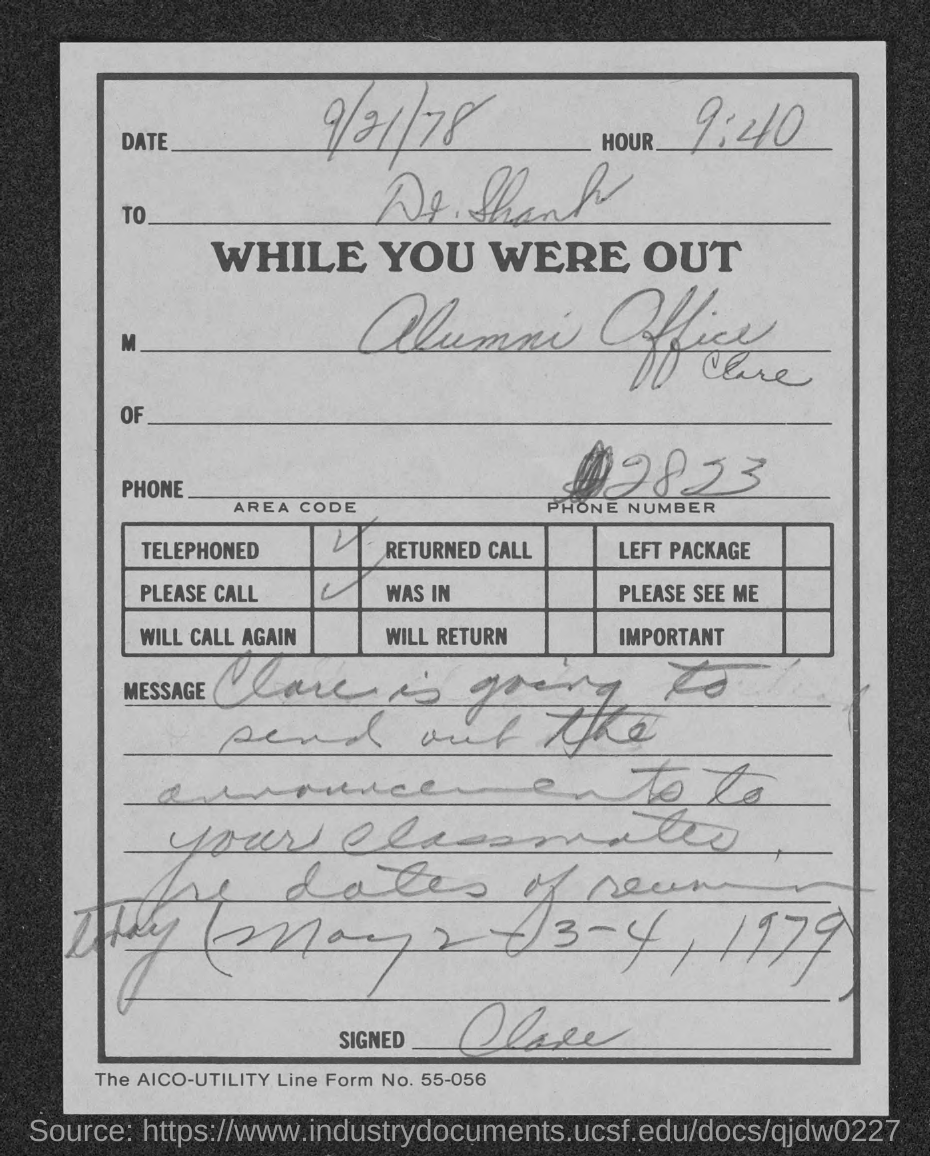What is the aico-utility line form no.?
Provide a succinct answer. 55-056. 